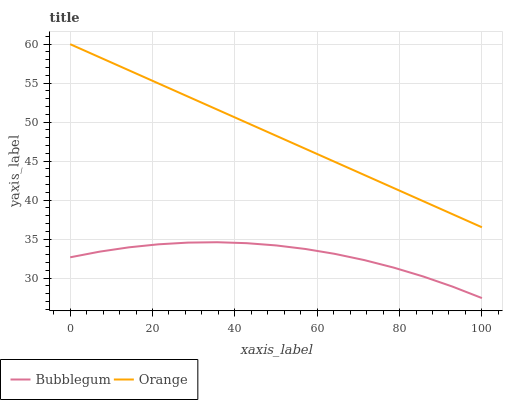Does Bubblegum have the minimum area under the curve?
Answer yes or no. Yes. Does Orange have the maximum area under the curve?
Answer yes or no. Yes. Does Bubblegum have the maximum area under the curve?
Answer yes or no. No. Is Orange the smoothest?
Answer yes or no. Yes. Is Bubblegum the roughest?
Answer yes or no. Yes. Is Bubblegum the smoothest?
Answer yes or no. No. Does Bubblegum have the lowest value?
Answer yes or no. Yes. Does Orange have the highest value?
Answer yes or no. Yes. Does Bubblegum have the highest value?
Answer yes or no. No. Is Bubblegum less than Orange?
Answer yes or no. Yes. Is Orange greater than Bubblegum?
Answer yes or no. Yes. Does Bubblegum intersect Orange?
Answer yes or no. No. 